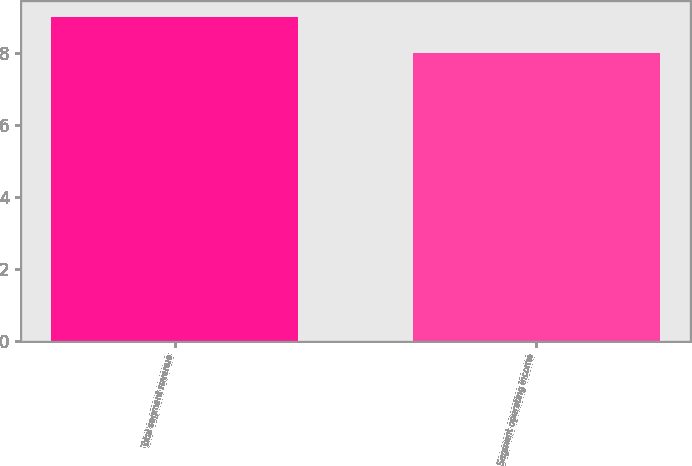<chart> <loc_0><loc_0><loc_500><loc_500><bar_chart><fcel>Total segment revenue<fcel>Segment operating income<nl><fcel>9<fcel>8<nl></chart> 